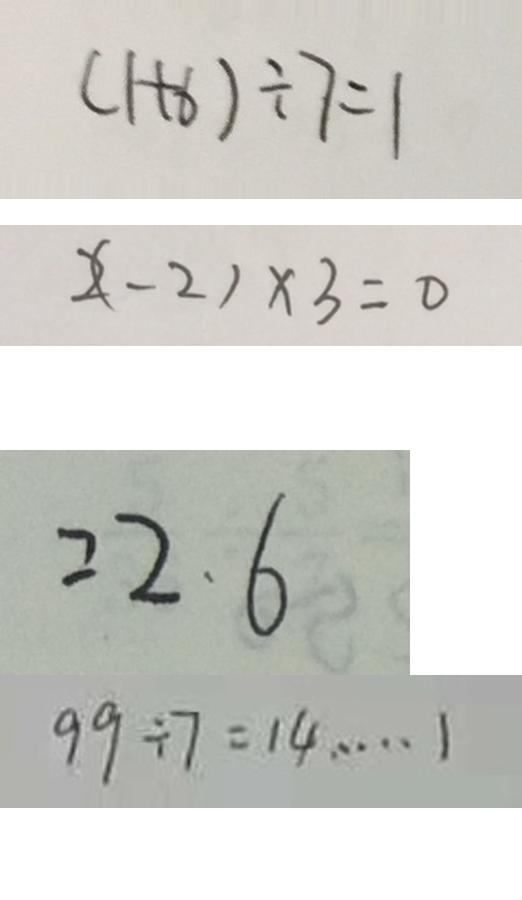Convert formula to latex. <formula><loc_0><loc_0><loc_500><loc_500>( 1 + 6 ) \div 7 = 1 
 ( 2 - 2 ) \times 3 = 0 
 = 2 . 6 
 9 9 \div 7 = 1 4 \cdots 1</formula> 